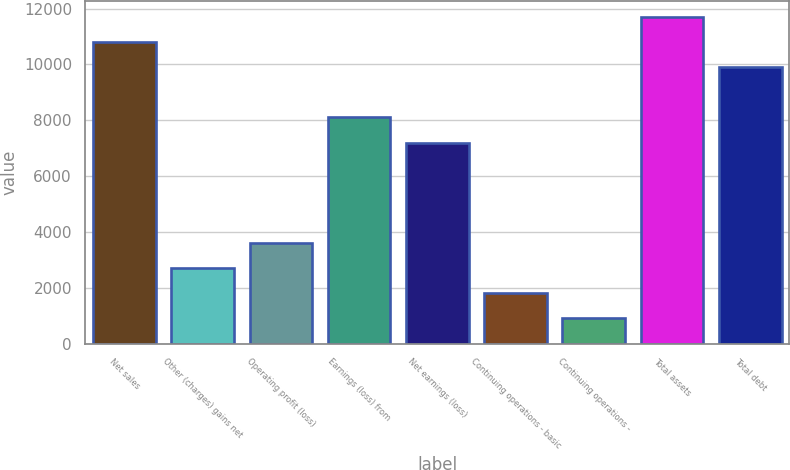<chart> <loc_0><loc_0><loc_500><loc_500><bar_chart><fcel>Net sales<fcel>Other (charges) gains net<fcel>Operating profit (loss)<fcel>Earnings (loss) from<fcel>Net earnings (loss)<fcel>Continuing operations - basic<fcel>Continuing operations -<fcel>Total assets<fcel>Total debt<nl><fcel>10799.9<fcel>2700.18<fcel>3600.15<fcel>8100<fcel>7200.03<fcel>1800.21<fcel>900.24<fcel>11699.9<fcel>9899.94<nl></chart> 